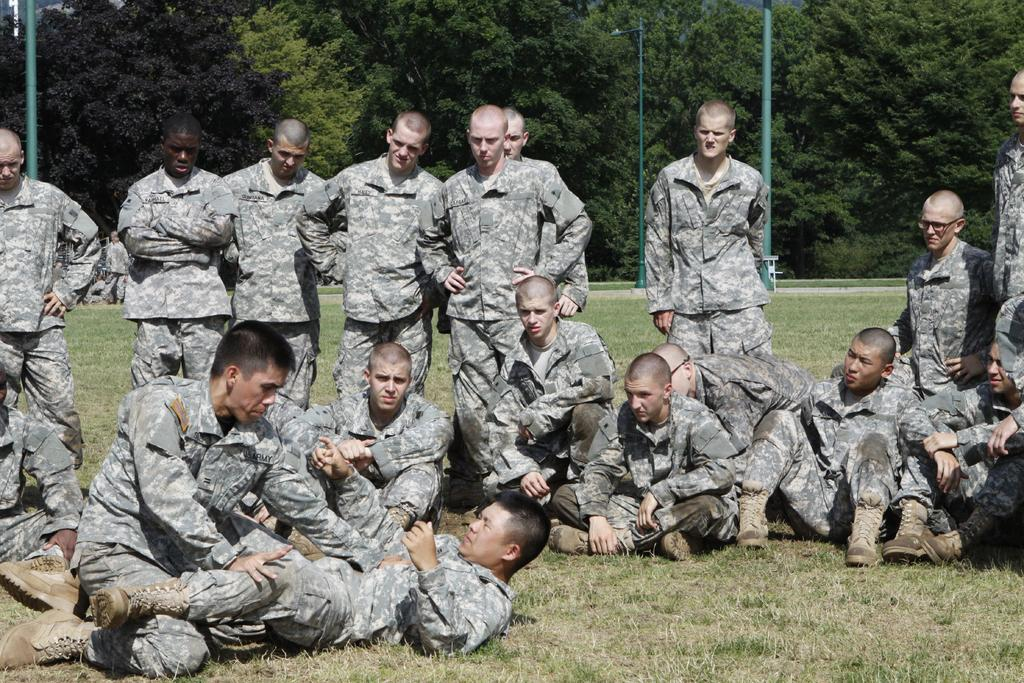What are the people in the image wearing? The people in the image are wearing uniforms. What position are some of the people in? Some people are sitting on the ground. What is the position of the person lying down in the image? There is a person lying down in the image. What can be seen in the background of the image? There are poles and trees visible in the background of the image. What type of laughter can be heard coming from the band in the image? There is no band present in the image, so it's not possible to determine what type of laughter might be heard. 